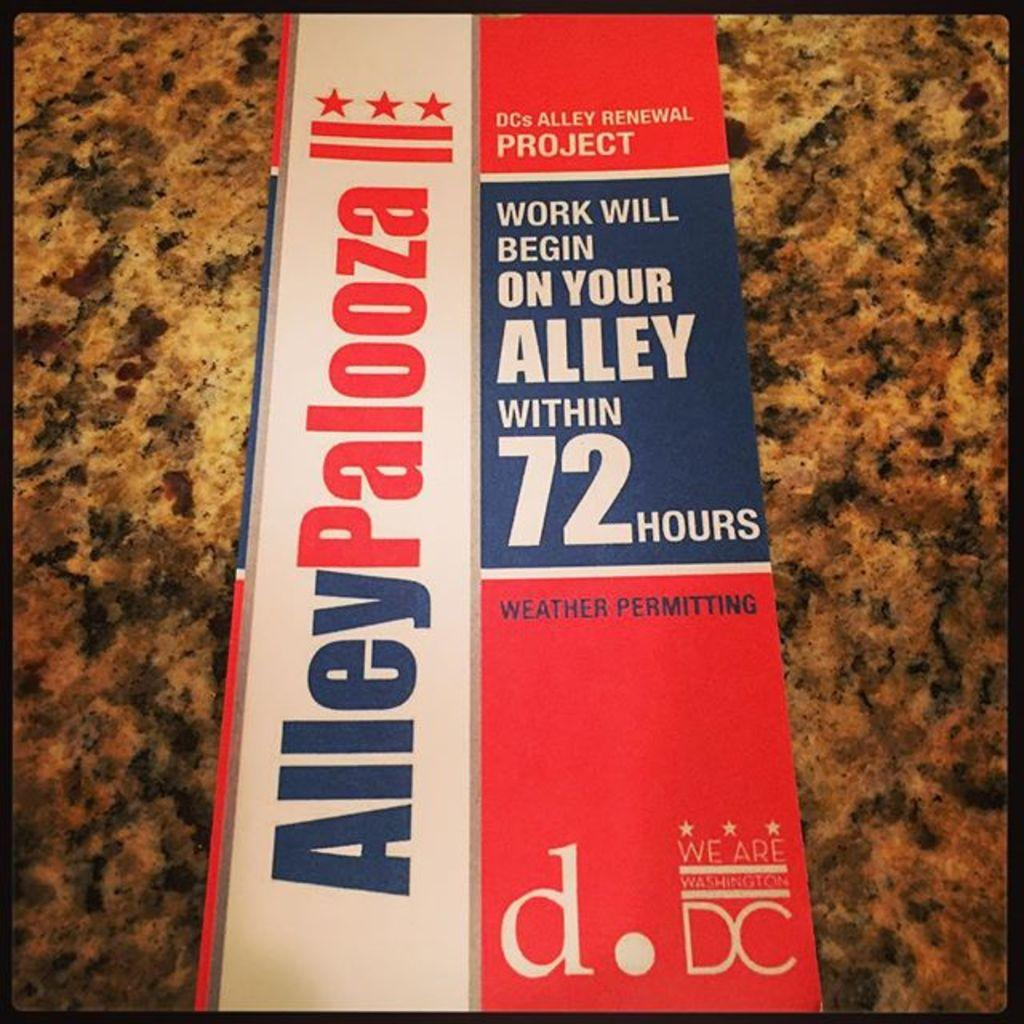Provide a one-sentence caption for the provided image. A red, white, and blue pamphlet about the DC Alley Renewal project. 